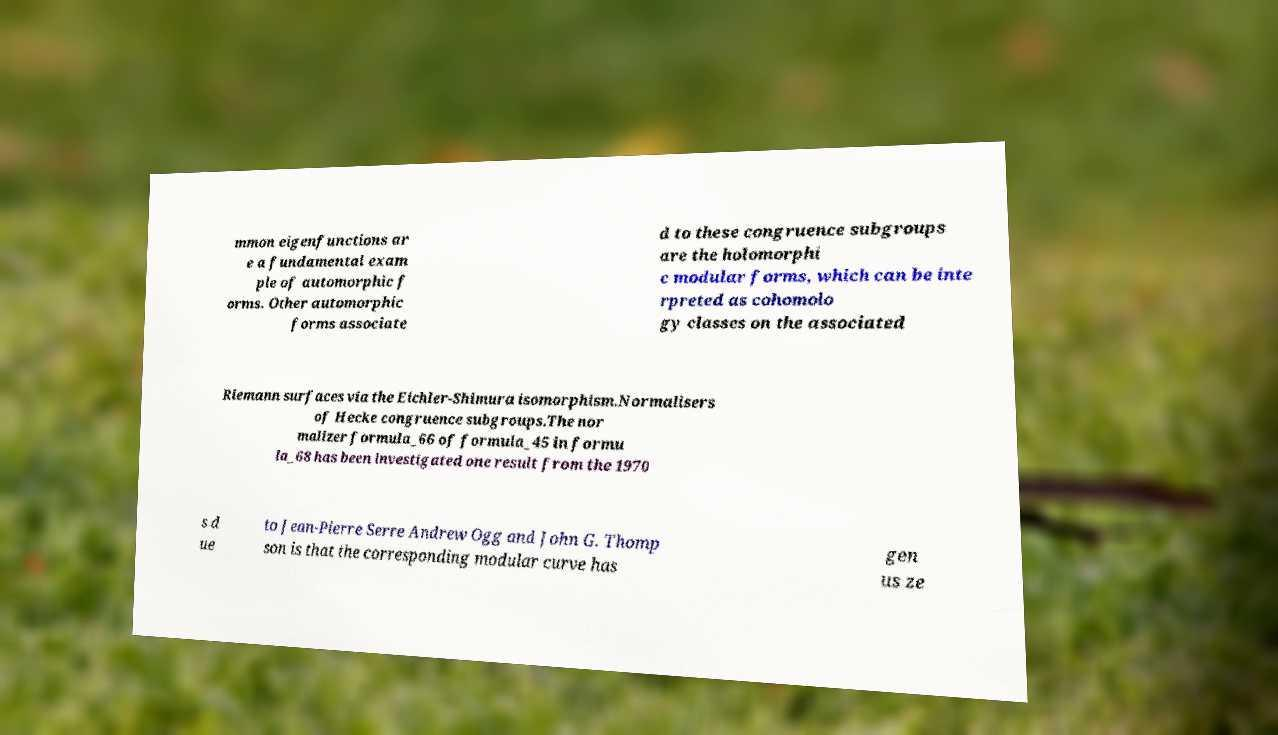There's text embedded in this image that I need extracted. Can you transcribe it verbatim? mmon eigenfunctions ar e a fundamental exam ple of automorphic f orms. Other automorphic forms associate d to these congruence subgroups are the holomorphi c modular forms, which can be inte rpreted as cohomolo gy classes on the associated Riemann surfaces via the Eichler-Shimura isomorphism.Normalisers of Hecke congruence subgroups.The nor malizer formula_66 of formula_45 in formu la_68 has been investigated one result from the 1970 s d ue to Jean-Pierre Serre Andrew Ogg and John G. Thomp son is that the corresponding modular curve has gen us ze 